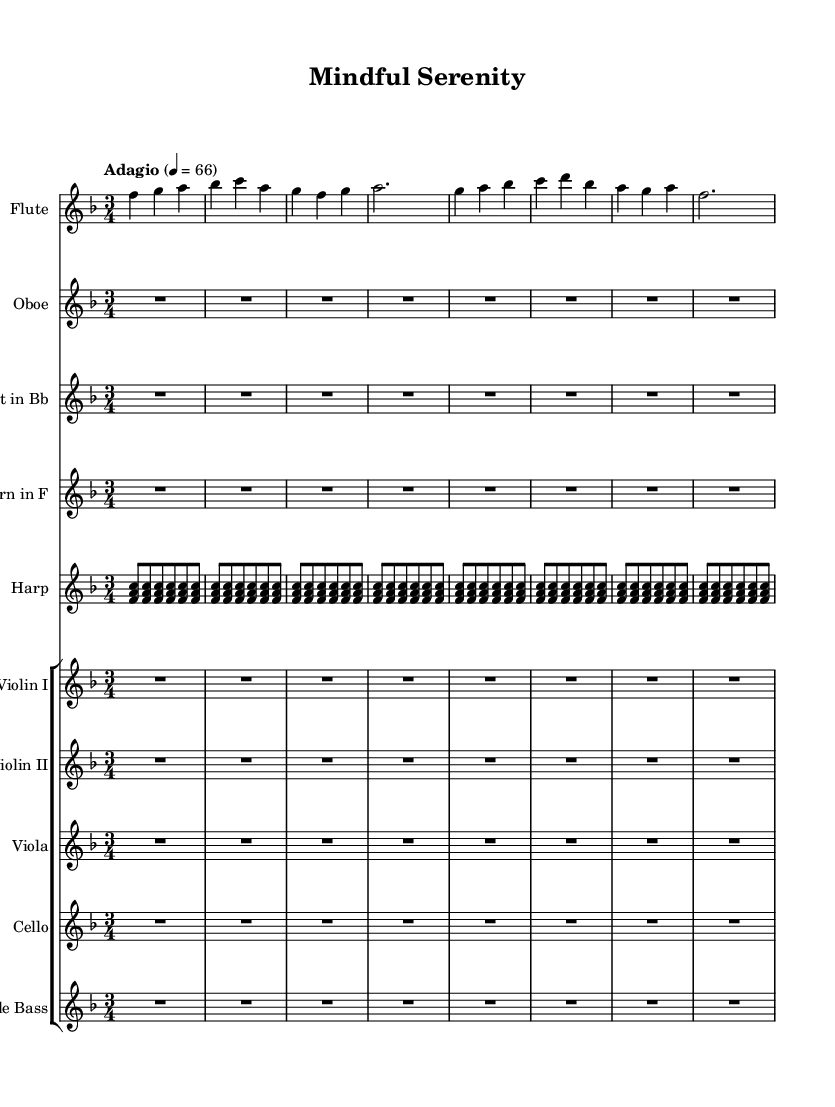What is the key signature of this music? The key signature is F major, identified by the presence of one flat, which is B flat.
Answer: F major What is the time signature of this music? The time signature is 3/4, as indicated at the beginning of the sheet music, meaning there are three beats per measure, and the quarter note gets one beat.
Answer: 3/4 What is the tempo marking of this music? The tempo marking is Adagio, which indicates a slow tempo, defined in the music as 66 beats per minute.
Answer: Adagio How many measures are there in the flute part? The flute part has eight measures, which can be counted directly from the notation provided.
Answer: 8 Which instrument has rest notes and does not play any notes in the given section? The oboe, clarinet, horn, violin I, violin II, viola, cello, and double bass sections all rest the entire time in this excerpt, indicated by all the rest symbols.
Answer: Oboe Which instruments play during the first couple of measures? The instruments participating in the first couple of measures are flute and harp, as shown by their respective notations in the first and second measures.
Answer: Flute, Harp What is the pattern followed by the harp chords? The harp follows a repeated chord pattern of F, A, and C in the same rhythmic structure, indicating a consistent harmonic foundation.
Answer: Repeated F, A, C 